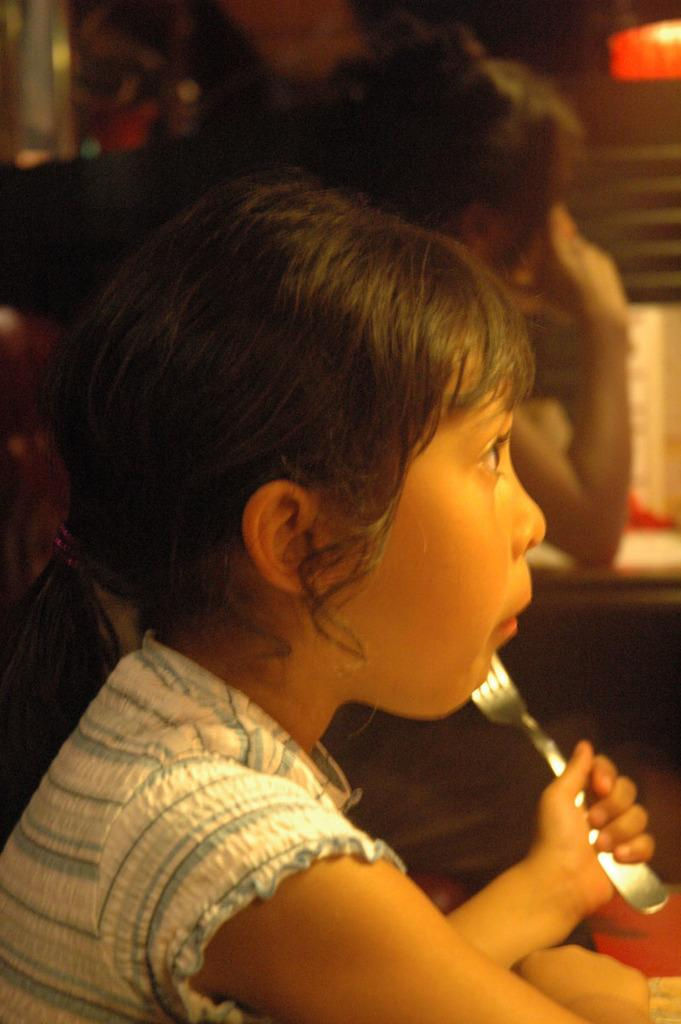Who is the main subject in the image? There is a girl in the image. What is the girl holding in her hand? The girl is holding a fork in her hand. Can you describe the background of the image? There is a person in the background of the image. What can be seen in the top right-hand side of the image? There is a light visible in the top right-hand side of the image. How many knees are visible in the image? There is no mention of knees in the provided facts, so it is impossible to determine the number of knees visible in the image. 